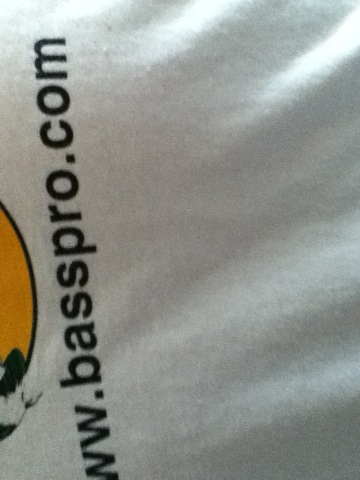Can you describe the logo on this shirt? The logo on the shirt likely represents a fish, which is consistent with the branding of Bass Pro Shops, a company known for its fishing and outdoor gear. 